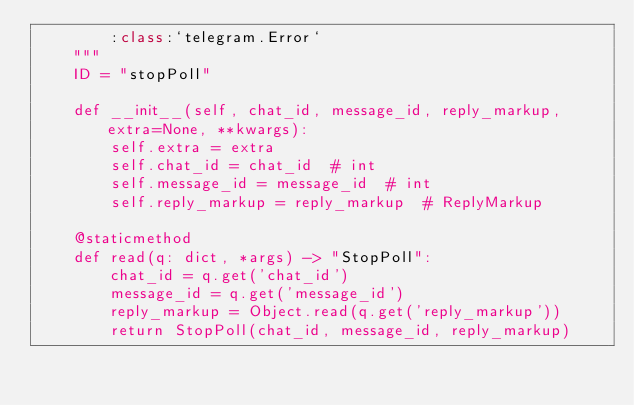<code> <loc_0><loc_0><loc_500><loc_500><_Python_>        :class:`telegram.Error`
    """
    ID = "stopPoll"

    def __init__(self, chat_id, message_id, reply_markup, extra=None, **kwargs):
        self.extra = extra
        self.chat_id = chat_id  # int
        self.message_id = message_id  # int
        self.reply_markup = reply_markup  # ReplyMarkup

    @staticmethod
    def read(q: dict, *args) -> "StopPoll":
        chat_id = q.get('chat_id')
        message_id = q.get('message_id')
        reply_markup = Object.read(q.get('reply_markup'))
        return StopPoll(chat_id, message_id, reply_markup)
</code> 